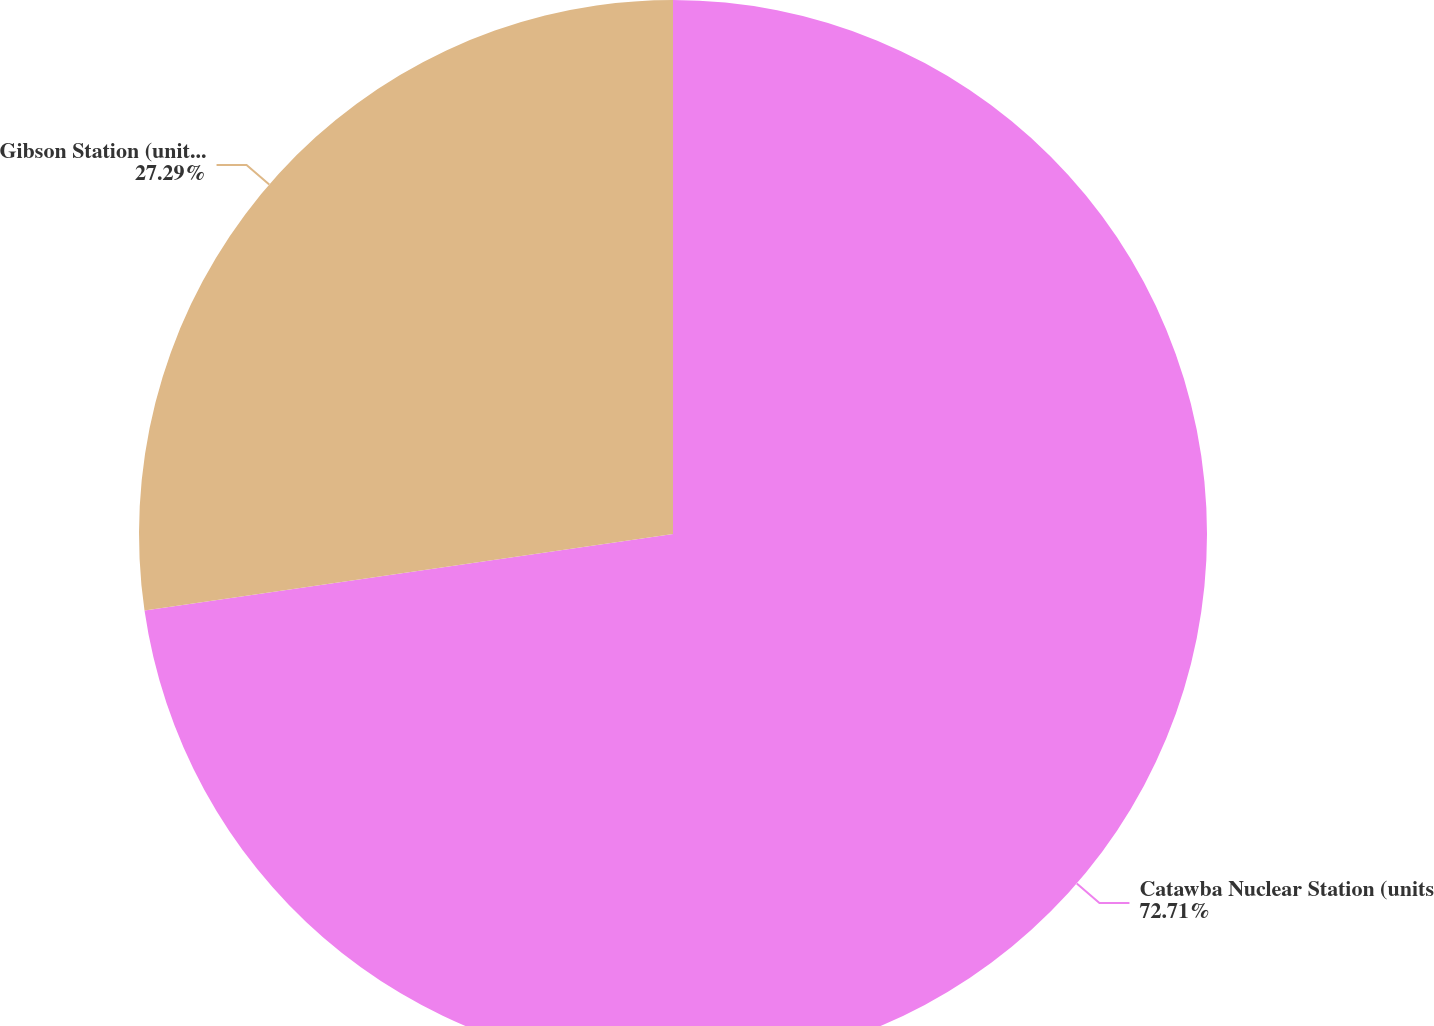Convert chart. <chart><loc_0><loc_0><loc_500><loc_500><pie_chart><fcel>Catawba Nuclear Station (units<fcel>Gibson Station (unit 5) (d)<nl><fcel>72.71%<fcel>27.29%<nl></chart> 